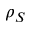<formula> <loc_0><loc_0><loc_500><loc_500>\rho _ { S }</formula> 